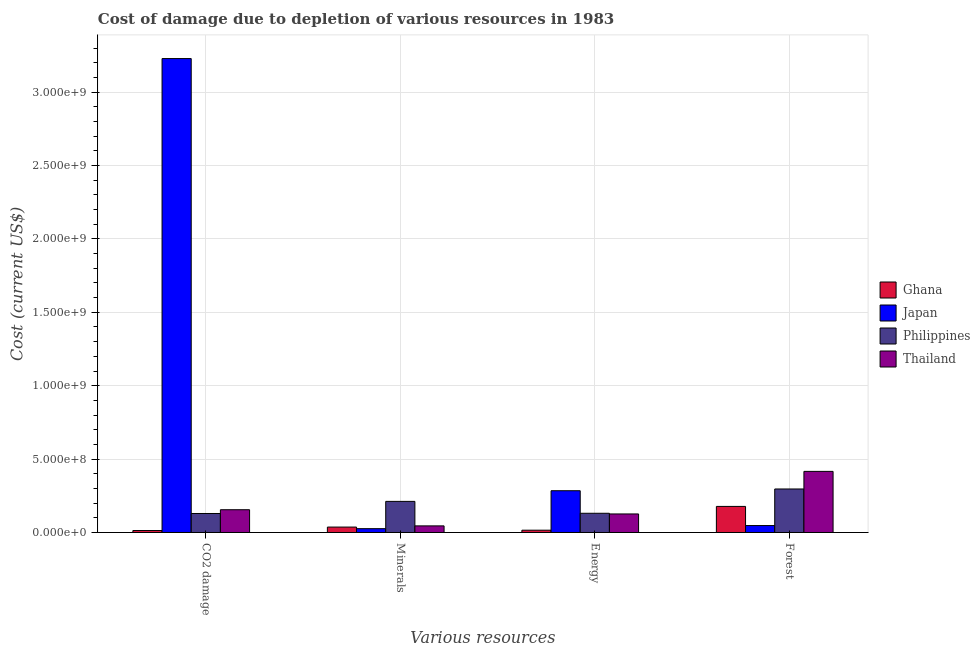How many groups of bars are there?
Give a very brief answer. 4. How many bars are there on the 3rd tick from the right?
Your answer should be very brief. 4. What is the label of the 1st group of bars from the left?
Your response must be concise. CO2 damage. What is the cost of damage due to depletion of coal in Japan?
Your response must be concise. 3.23e+09. Across all countries, what is the maximum cost of damage due to depletion of minerals?
Ensure brevity in your answer.  2.12e+08. Across all countries, what is the minimum cost of damage due to depletion of minerals?
Your answer should be compact. 2.60e+07. In which country was the cost of damage due to depletion of coal minimum?
Provide a short and direct response. Ghana. What is the total cost of damage due to depletion of energy in the graph?
Your answer should be very brief. 5.57e+08. What is the difference between the cost of damage due to depletion of forests in Japan and that in Thailand?
Your answer should be very brief. -3.69e+08. What is the difference between the cost of damage due to depletion of coal in Thailand and the cost of damage due to depletion of forests in Ghana?
Your response must be concise. -2.26e+07. What is the average cost of damage due to depletion of minerals per country?
Provide a succinct answer. 7.99e+07. What is the difference between the cost of damage due to depletion of forests and cost of damage due to depletion of coal in Thailand?
Give a very brief answer. 2.61e+08. In how many countries, is the cost of damage due to depletion of energy greater than 2600000000 US$?
Keep it short and to the point. 0. What is the ratio of the cost of damage due to depletion of forests in Philippines to that in Thailand?
Provide a short and direct response. 0.71. Is the cost of damage due to depletion of energy in Japan less than that in Thailand?
Keep it short and to the point. No. What is the difference between the highest and the second highest cost of damage due to depletion of coal?
Your answer should be compact. 3.07e+09. What is the difference between the highest and the lowest cost of damage due to depletion of coal?
Offer a very short reply. 3.22e+09. Is the sum of the cost of damage due to depletion of forests in Japan and Philippines greater than the maximum cost of damage due to depletion of minerals across all countries?
Offer a very short reply. Yes. What does the 2nd bar from the left in Minerals represents?
Give a very brief answer. Japan. What does the 2nd bar from the right in Forest represents?
Make the answer very short. Philippines. What is the difference between two consecutive major ticks on the Y-axis?
Keep it short and to the point. 5.00e+08. How many legend labels are there?
Offer a terse response. 4. What is the title of the graph?
Provide a short and direct response. Cost of damage due to depletion of various resources in 1983 . Does "Low & middle income" appear as one of the legend labels in the graph?
Provide a succinct answer. No. What is the label or title of the X-axis?
Ensure brevity in your answer.  Various resources. What is the label or title of the Y-axis?
Your response must be concise. Cost (current US$). What is the Cost (current US$) in Ghana in CO2 damage?
Keep it short and to the point. 1.34e+07. What is the Cost (current US$) of Japan in CO2 damage?
Your answer should be compact. 3.23e+09. What is the Cost (current US$) in Philippines in CO2 damage?
Your answer should be compact. 1.29e+08. What is the Cost (current US$) in Thailand in CO2 damage?
Your answer should be very brief. 1.55e+08. What is the Cost (current US$) in Ghana in Minerals?
Make the answer very short. 3.69e+07. What is the Cost (current US$) in Japan in Minerals?
Keep it short and to the point. 2.60e+07. What is the Cost (current US$) in Philippines in Minerals?
Your answer should be very brief. 2.12e+08. What is the Cost (current US$) in Thailand in Minerals?
Make the answer very short. 4.49e+07. What is the Cost (current US$) in Ghana in Energy?
Keep it short and to the point. 1.56e+07. What is the Cost (current US$) in Japan in Energy?
Your answer should be very brief. 2.84e+08. What is the Cost (current US$) in Philippines in Energy?
Offer a very short reply. 1.31e+08. What is the Cost (current US$) in Thailand in Energy?
Your answer should be very brief. 1.26e+08. What is the Cost (current US$) in Ghana in Forest?
Make the answer very short. 1.78e+08. What is the Cost (current US$) of Japan in Forest?
Offer a terse response. 4.72e+07. What is the Cost (current US$) in Philippines in Forest?
Offer a terse response. 2.96e+08. What is the Cost (current US$) of Thailand in Forest?
Your response must be concise. 4.16e+08. Across all Various resources, what is the maximum Cost (current US$) of Ghana?
Your answer should be very brief. 1.78e+08. Across all Various resources, what is the maximum Cost (current US$) in Japan?
Keep it short and to the point. 3.23e+09. Across all Various resources, what is the maximum Cost (current US$) of Philippines?
Ensure brevity in your answer.  2.96e+08. Across all Various resources, what is the maximum Cost (current US$) of Thailand?
Ensure brevity in your answer.  4.16e+08. Across all Various resources, what is the minimum Cost (current US$) of Ghana?
Offer a terse response. 1.34e+07. Across all Various resources, what is the minimum Cost (current US$) in Japan?
Ensure brevity in your answer.  2.60e+07. Across all Various resources, what is the minimum Cost (current US$) of Philippines?
Ensure brevity in your answer.  1.29e+08. Across all Various resources, what is the minimum Cost (current US$) in Thailand?
Offer a very short reply. 4.49e+07. What is the total Cost (current US$) of Ghana in the graph?
Your response must be concise. 2.44e+08. What is the total Cost (current US$) of Japan in the graph?
Your response must be concise. 3.59e+09. What is the total Cost (current US$) of Philippines in the graph?
Give a very brief answer. 7.68e+08. What is the total Cost (current US$) of Thailand in the graph?
Provide a succinct answer. 7.42e+08. What is the difference between the Cost (current US$) of Ghana in CO2 damage and that in Minerals?
Keep it short and to the point. -2.35e+07. What is the difference between the Cost (current US$) in Japan in CO2 damage and that in Minerals?
Give a very brief answer. 3.20e+09. What is the difference between the Cost (current US$) in Philippines in CO2 damage and that in Minerals?
Keep it short and to the point. -8.25e+07. What is the difference between the Cost (current US$) of Thailand in CO2 damage and that in Minerals?
Give a very brief answer. 1.10e+08. What is the difference between the Cost (current US$) of Ghana in CO2 damage and that in Energy?
Keep it short and to the point. -2.28e+06. What is the difference between the Cost (current US$) in Japan in CO2 damage and that in Energy?
Offer a very short reply. 2.94e+09. What is the difference between the Cost (current US$) of Philippines in CO2 damage and that in Energy?
Your response must be concise. -1.48e+06. What is the difference between the Cost (current US$) in Thailand in CO2 damage and that in Energy?
Keep it short and to the point. 2.88e+07. What is the difference between the Cost (current US$) in Ghana in CO2 damage and that in Forest?
Keep it short and to the point. -1.64e+08. What is the difference between the Cost (current US$) in Japan in CO2 damage and that in Forest?
Offer a terse response. 3.18e+09. What is the difference between the Cost (current US$) of Philippines in CO2 damage and that in Forest?
Provide a succinct answer. -1.67e+08. What is the difference between the Cost (current US$) in Thailand in CO2 damage and that in Forest?
Make the answer very short. -2.61e+08. What is the difference between the Cost (current US$) of Ghana in Minerals and that in Energy?
Make the answer very short. 2.13e+07. What is the difference between the Cost (current US$) of Japan in Minerals and that in Energy?
Make the answer very short. -2.58e+08. What is the difference between the Cost (current US$) of Philippines in Minerals and that in Energy?
Make the answer very short. 8.10e+07. What is the difference between the Cost (current US$) of Thailand in Minerals and that in Energy?
Offer a terse response. -8.13e+07. What is the difference between the Cost (current US$) of Ghana in Minerals and that in Forest?
Keep it short and to the point. -1.41e+08. What is the difference between the Cost (current US$) in Japan in Minerals and that in Forest?
Keep it short and to the point. -2.12e+07. What is the difference between the Cost (current US$) of Philippines in Minerals and that in Forest?
Make the answer very short. -8.45e+07. What is the difference between the Cost (current US$) in Thailand in Minerals and that in Forest?
Your response must be concise. -3.71e+08. What is the difference between the Cost (current US$) of Ghana in Energy and that in Forest?
Your answer should be very brief. -1.62e+08. What is the difference between the Cost (current US$) of Japan in Energy and that in Forest?
Provide a short and direct response. 2.37e+08. What is the difference between the Cost (current US$) of Philippines in Energy and that in Forest?
Provide a short and direct response. -1.66e+08. What is the difference between the Cost (current US$) in Thailand in Energy and that in Forest?
Give a very brief answer. -2.90e+08. What is the difference between the Cost (current US$) of Ghana in CO2 damage and the Cost (current US$) of Japan in Minerals?
Offer a terse response. -1.27e+07. What is the difference between the Cost (current US$) in Ghana in CO2 damage and the Cost (current US$) in Philippines in Minerals?
Provide a succinct answer. -1.99e+08. What is the difference between the Cost (current US$) of Ghana in CO2 damage and the Cost (current US$) of Thailand in Minerals?
Give a very brief answer. -3.16e+07. What is the difference between the Cost (current US$) in Japan in CO2 damage and the Cost (current US$) in Philippines in Minerals?
Offer a very short reply. 3.02e+09. What is the difference between the Cost (current US$) of Japan in CO2 damage and the Cost (current US$) of Thailand in Minerals?
Offer a very short reply. 3.18e+09. What is the difference between the Cost (current US$) in Philippines in CO2 damage and the Cost (current US$) in Thailand in Minerals?
Your answer should be very brief. 8.44e+07. What is the difference between the Cost (current US$) in Ghana in CO2 damage and the Cost (current US$) in Japan in Energy?
Provide a short and direct response. -2.71e+08. What is the difference between the Cost (current US$) in Ghana in CO2 damage and the Cost (current US$) in Philippines in Energy?
Ensure brevity in your answer.  -1.17e+08. What is the difference between the Cost (current US$) of Ghana in CO2 damage and the Cost (current US$) of Thailand in Energy?
Offer a very short reply. -1.13e+08. What is the difference between the Cost (current US$) of Japan in CO2 damage and the Cost (current US$) of Philippines in Energy?
Your answer should be compact. 3.10e+09. What is the difference between the Cost (current US$) in Japan in CO2 damage and the Cost (current US$) in Thailand in Energy?
Ensure brevity in your answer.  3.10e+09. What is the difference between the Cost (current US$) in Philippines in CO2 damage and the Cost (current US$) in Thailand in Energy?
Offer a terse response. 3.09e+06. What is the difference between the Cost (current US$) of Ghana in CO2 damage and the Cost (current US$) of Japan in Forest?
Offer a terse response. -3.39e+07. What is the difference between the Cost (current US$) of Ghana in CO2 damage and the Cost (current US$) of Philippines in Forest?
Provide a succinct answer. -2.83e+08. What is the difference between the Cost (current US$) of Ghana in CO2 damage and the Cost (current US$) of Thailand in Forest?
Keep it short and to the point. -4.03e+08. What is the difference between the Cost (current US$) in Japan in CO2 damage and the Cost (current US$) in Philippines in Forest?
Provide a short and direct response. 2.93e+09. What is the difference between the Cost (current US$) in Japan in CO2 damage and the Cost (current US$) in Thailand in Forest?
Make the answer very short. 2.81e+09. What is the difference between the Cost (current US$) of Philippines in CO2 damage and the Cost (current US$) of Thailand in Forest?
Offer a very short reply. -2.87e+08. What is the difference between the Cost (current US$) in Ghana in Minerals and the Cost (current US$) in Japan in Energy?
Offer a terse response. -2.48e+08. What is the difference between the Cost (current US$) in Ghana in Minerals and the Cost (current US$) in Philippines in Energy?
Provide a succinct answer. -9.39e+07. What is the difference between the Cost (current US$) in Ghana in Minerals and the Cost (current US$) in Thailand in Energy?
Make the answer very short. -8.94e+07. What is the difference between the Cost (current US$) in Japan in Minerals and the Cost (current US$) in Philippines in Energy?
Keep it short and to the point. -1.05e+08. What is the difference between the Cost (current US$) of Japan in Minerals and the Cost (current US$) of Thailand in Energy?
Offer a terse response. -1.00e+08. What is the difference between the Cost (current US$) in Philippines in Minerals and the Cost (current US$) in Thailand in Energy?
Offer a very short reply. 8.56e+07. What is the difference between the Cost (current US$) in Ghana in Minerals and the Cost (current US$) in Japan in Forest?
Your response must be concise. -1.03e+07. What is the difference between the Cost (current US$) in Ghana in Minerals and the Cost (current US$) in Philippines in Forest?
Offer a terse response. -2.59e+08. What is the difference between the Cost (current US$) in Ghana in Minerals and the Cost (current US$) in Thailand in Forest?
Give a very brief answer. -3.79e+08. What is the difference between the Cost (current US$) in Japan in Minerals and the Cost (current US$) in Philippines in Forest?
Ensure brevity in your answer.  -2.70e+08. What is the difference between the Cost (current US$) in Japan in Minerals and the Cost (current US$) in Thailand in Forest?
Your answer should be compact. -3.90e+08. What is the difference between the Cost (current US$) of Philippines in Minerals and the Cost (current US$) of Thailand in Forest?
Ensure brevity in your answer.  -2.04e+08. What is the difference between the Cost (current US$) in Ghana in Energy and the Cost (current US$) in Japan in Forest?
Keep it short and to the point. -3.16e+07. What is the difference between the Cost (current US$) of Ghana in Energy and the Cost (current US$) of Philippines in Forest?
Your response must be concise. -2.81e+08. What is the difference between the Cost (current US$) in Ghana in Energy and the Cost (current US$) in Thailand in Forest?
Keep it short and to the point. -4.01e+08. What is the difference between the Cost (current US$) of Japan in Energy and the Cost (current US$) of Philippines in Forest?
Your answer should be very brief. -1.19e+07. What is the difference between the Cost (current US$) of Japan in Energy and the Cost (current US$) of Thailand in Forest?
Your answer should be very brief. -1.32e+08. What is the difference between the Cost (current US$) in Philippines in Energy and the Cost (current US$) in Thailand in Forest?
Your answer should be very brief. -2.85e+08. What is the average Cost (current US$) of Ghana per Various resources?
Your response must be concise. 6.09e+07. What is the average Cost (current US$) in Japan per Various resources?
Provide a short and direct response. 8.97e+08. What is the average Cost (current US$) in Philippines per Various resources?
Offer a terse response. 1.92e+08. What is the average Cost (current US$) in Thailand per Various resources?
Give a very brief answer. 1.86e+08. What is the difference between the Cost (current US$) of Ghana and Cost (current US$) of Japan in CO2 damage?
Your answer should be very brief. -3.22e+09. What is the difference between the Cost (current US$) in Ghana and Cost (current US$) in Philippines in CO2 damage?
Offer a terse response. -1.16e+08. What is the difference between the Cost (current US$) of Ghana and Cost (current US$) of Thailand in CO2 damage?
Your answer should be very brief. -1.42e+08. What is the difference between the Cost (current US$) of Japan and Cost (current US$) of Philippines in CO2 damage?
Offer a terse response. 3.10e+09. What is the difference between the Cost (current US$) of Japan and Cost (current US$) of Thailand in CO2 damage?
Your response must be concise. 3.07e+09. What is the difference between the Cost (current US$) of Philippines and Cost (current US$) of Thailand in CO2 damage?
Provide a succinct answer. -2.57e+07. What is the difference between the Cost (current US$) in Ghana and Cost (current US$) in Japan in Minerals?
Your answer should be compact. 1.09e+07. What is the difference between the Cost (current US$) of Ghana and Cost (current US$) of Philippines in Minerals?
Provide a succinct answer. -1.75e+08. What is the difference between the Cost (current US$) in Ghana and Cost (current US$) in Thailand in Minerals?
Offer a very short reply. -8.06e+06. What is the difference between the Cost (current US$) of Japan and Cost (current US$) of Philippines in Minerals?
Your answer should be very brief. -1.86e+08. What is the difference between the Cost (current US$) in Japan and Cost (current US$) in Thailand in Minerals?
Give a very brief answer. -1.89e+07. What is the difference between the Cost (current US$) in Philippines and Cost (current US$) in Thailand in Minerals?
Offer a very short reply. 1.67e+08. What is the difference between the Cost (current US$) of Ghana and Cost (current US$) of Japan in Energy?
Make the answer very short. -2.69e+08. What is the difference between the Cost (current US$) of Ghana and Cost (current US$) of Philippines in Energy?
Offer a very short reply. -1.15e+08. What is the difference between the Cost (current US$) in Ghana and Cost (current US$) in Thailand in Energy?
Offer a terse response. -1.11e+08. What is the difference between the Cost (current US$) of Japan and Cost (current US$) of Philippines in Energy?
Offer a very short reply. 1.54e+08. What is the difference between the Cost (current US$) in Japan and Cost (current US$) in Thailand in Energy?
Make the answer very short. 1.58e+08. What is the difference between the Cost (current US$) of Philippines and Cost (current US$) of Thailand in Energy?
Your response must be concise. 4.57e+06. What is the difference between the Cost (current US$) in Ghana and Cost (current US$) in Japan in Forest?
Provide a short and direct response. 1.30e+08. What is the difference between the Cost (current US$) in Ghana and Cost (current US$) in Philippines in Forest?
Offer a terse response. -1.19e+08. What is the difference between the Cost (current US$) in Ghana and Cost (current US$) in Thailand in Forest?
Your answer should be compact. -2.39e+08. What is the difference between the Cost (current US$) of Japan and Cost (current US$) of Philippines in Forest?
Give a very brief answer. -2.49e+08. What is the difference between the Cost (current US$) of Japan and Cost (current US$) of Thailand in Forest?
Offer a very short reply. -3.69e+08. What is the difference between the Cost (current US$) of Philippines and Cost (current US$) of Thailand in Forest?
Offer a terse response. -1.20e+08. What is the ratio of the Cost (current US$) of Ghana in CO2 damage to that in Minerals?
Give a very brief answer. 0.36. What is the ratio of the Cost (current US$) of Japan in CO2 damage to that in Minerals?
Provide a succinct answer. 124.13. What is the ratio of the Cost (current US$) in Philippines in CO2 damage to that in Minerals?
Ensure brevity in your answer.  0.61. What is the ratio of the Cost (current US$) in Thailand in CO2 damage to that in Minerals?
Ensure brevity in your answer.  3.45. What is the ratio of the Cost (current US$) in Ghana in CO2 damage to that in Energy?
Your answer should be compact. 0.85. What is the ratio of the Cost (current US$) of Japan in CO2 damage to that in Energy?
Your answer should be compact. 11.35. What is the ratio of the Cost (current US$) of Philippines in CO2 damage to that in Energy?
Your answer should be compact. 0.99. What is the ratio of the Cost (current US$) of Thailand in CO2 damage to that in Energy?
Your answer should be compact. 1.23. What is the ratio of the Cost (current US$) of Ghana in CO2 damage to that in Forest?
Provide a succinct answer. 0.08. What is the ratio of the Cost (current US$) of Japan in CO2 damage to that in Forest?
Ensure brevity in your answer.  68.39. What is the ratio of the Cost (current US$) in Philippines in CO2 damage to that in Forest?
Your answer should be compact. 0.44. What is the ratio of the Cost (current US$) of Thailand in CO2 damage to that in Forest?
Ensure brevity in your answer.  0.37. What is the ratio of the Cost (current US$) in Ghana in Minerals to that in Energy?
Offer a terse response. 2.36. What is the ratio of the Cost (current US$) of Japan in Minerals to that in Energy?
Make the answer very short. 0.09. What is the ratio of the Cost (current US$) of Philippines in Minerals to that in Energy?
Offer a terse response. 1.62. What is the ratio of the Cost (current US$) of Thailand in Minerals to that in Energy?
Offer a very short reply. 0.36. What is the ratio of the Cost (current US$) in Ghana in Minerals to that in Forest?
Give a very brief answer. 0.21. What is the ratio of the Cost (current US$) in Japan in Minerals to that in Forest?
Provide a short and direct response. 0.55. What is the ratio of the Cost (current US$) in Philippines in Minerals to that in Forest?
Provide a succinct answer. 0.71. What is the ratio of the Cost (current US$) of Thailand in Minerals to that in Forest?
Provide a succinct answer. 0.11. What is the ratio of the Cost (current US$) in Ghana in Energy to that in Forest?
Offer a very short reply. 0.09. What is the ratio of the Cost (current US$) of Japan in Energy to that in Forest?
Your answer should be very brief. 6.03. What is the ratio of the Cost (current US$) in Philippines in Energy to that in Forest?
Your answer should be very brief. 0.44. What is the ratio of the Cost (current US$) of Thailand in Energy to that in Forest?
Ensure brevity in your answer.  0.3. What is the difference between the highest and the second highest Cost (current US$) in Ghana?
Your answer should be very brief. 1.41e+08. What is the difference between the highest and the second highest Cost (current US$) of Japan?
Your response must be concise. 2.94e+09. What is the difference between the highest and the second highest Cost (current US$) of Philippines?
Ensure brevity in your answer.  8.45e+07. What is the difference between the highest and the second highest Cost (current US$) of Thailand?
Ensure brevity in your answer.  2.61e+08. What is the difference between the highest and the lowest Cost (current US$) of Ghana?
Keep it short and to the point. 1.64e+08. What is the difference between the highest and the lowest Cost (current US$) of Japan?
Ensure brevity in your answer.  3.20e+09. What is the difference between the highest and the lowest Cost (current US$) in Philippines?
Provide a short and direct response. 1.67e+08. What is the difference between the highest and the lowest Cost (current US$) of Thailand?
Keep it short and to the point. 3.71e+08. 